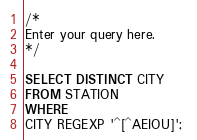Convert code to text. <code><loc_0><loc_0><loc_500><loc_500><_SQL_>/*
Enter your query here.
*/

SELECT DISTINCT CITY
FROM STATION
WHERE 
CITY REGEXP '^[^AEIOU]'; </code> 